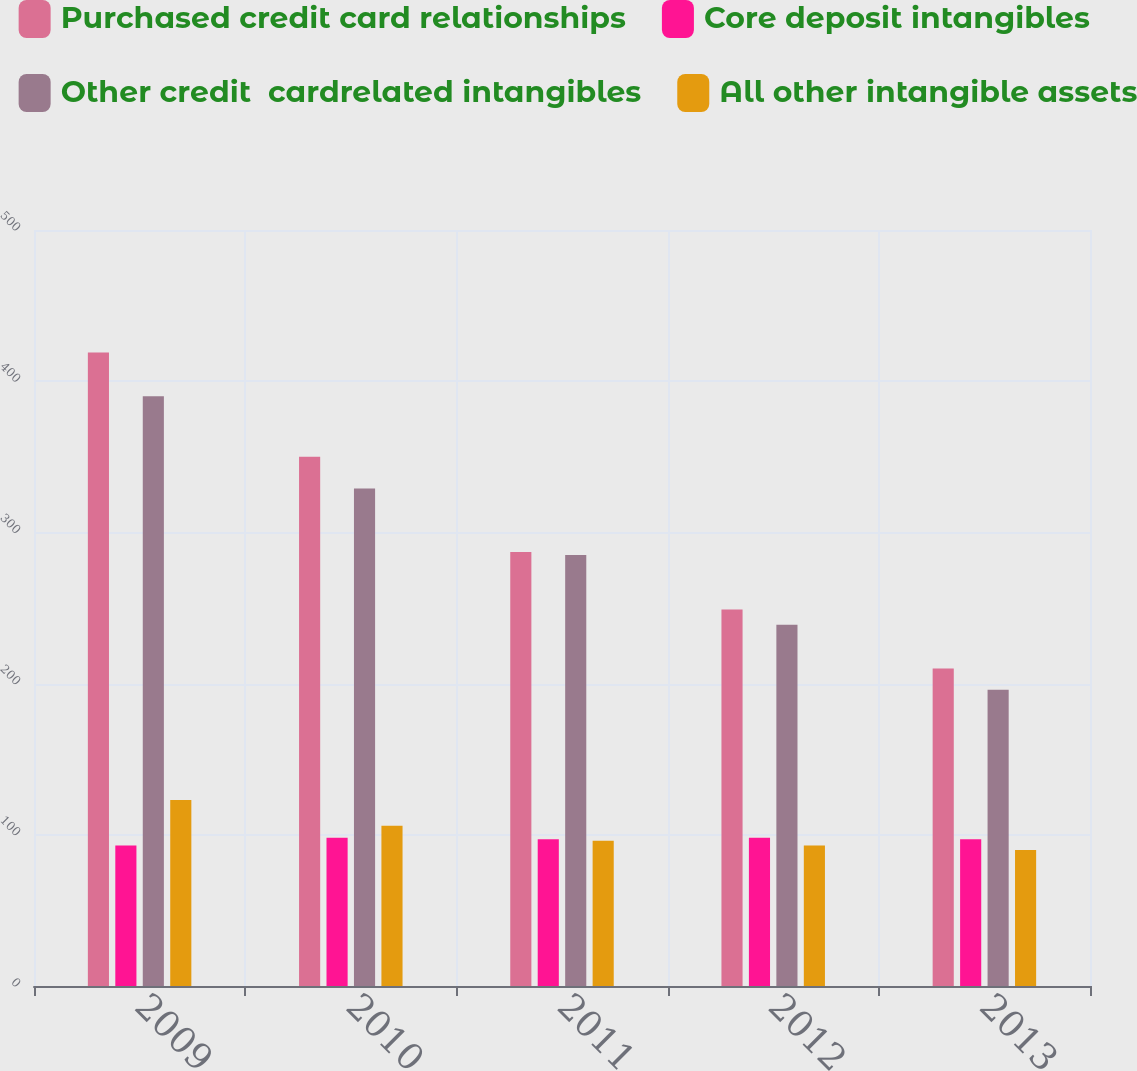Convert chart to OTSL. <chart><loc_0><loc_0><loc_500><loc_500><stacked_bar_chart><ecel><fcel>2009<fcel>2010<fcel>2011<fcel>2012<fcel>2013<nl><fcel>Purchased credit card relationships<fcel>419<fcel>350<fcel>287<fcel>249<fcel>210<nl><fcel>Core deposit intangibles<fcel>93<fcel>98<fcel>97<fcel>98<fcel>97<nl><fcel>Other credit  cardrelated intangibles<fcel>390<fcel>329<fcel>285<fcel>239<fcel>196<nl><fcel>All other intangible assets<fcel>123<fcel>106<fcel>96<fcel>93<fcel>90<nl></chart> 